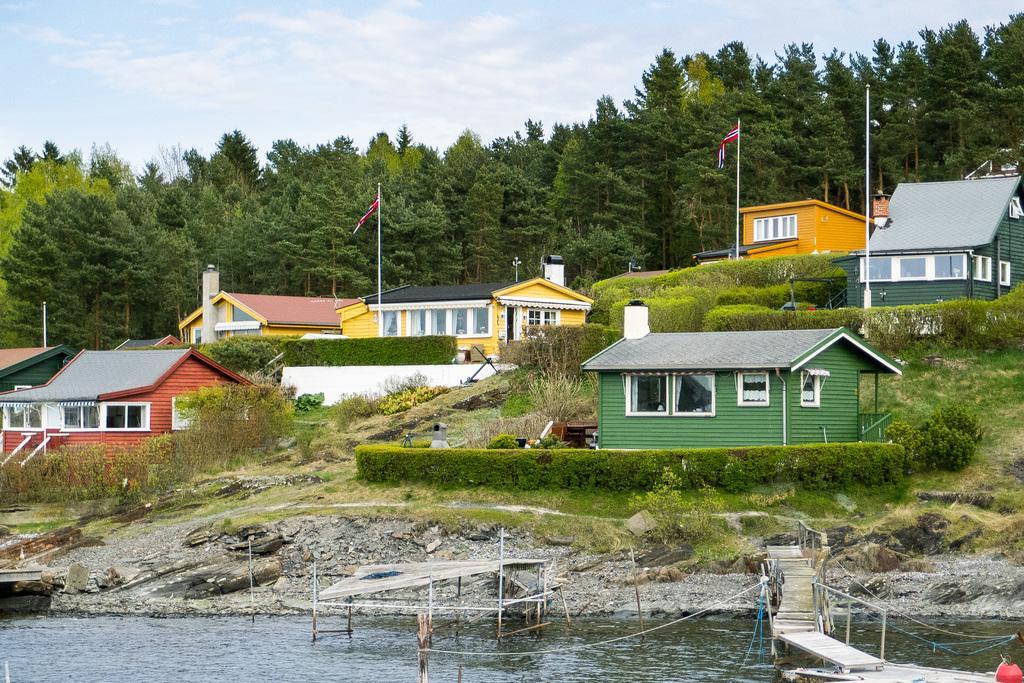Can you describe this image briefly? In this image I can see water, bridge, ropes, tent, grass, plants, houses, flagpoles, trees and the sky. This image is taken may be near the lake. 